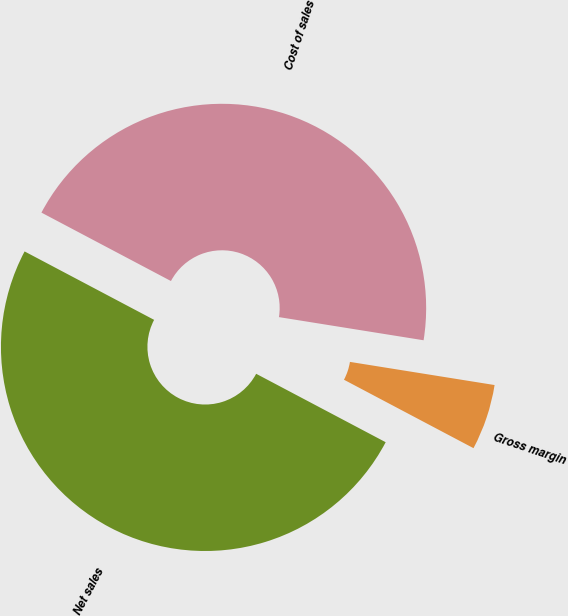Convert chart to OTSL. <chart><loc_0><loc_0><loc_500><loc_500><pie_chart><fcel>Net sales<fcel>Cost of sales<fcel>Gross margin<nl><fcel>50.0%<fcel>44.79%<fcel>5.21%<nl></chart> 